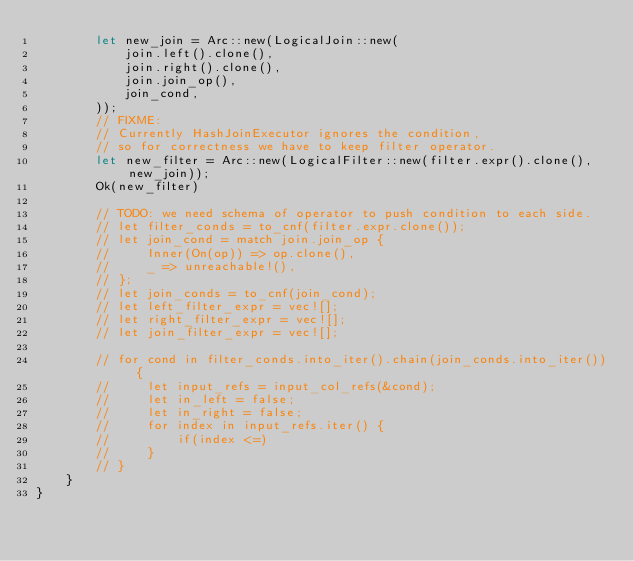<code> <loc_0><loc_0><loc_500><loc_500><_Rust_>        let new_join = Arc::new(LogicalJoin::new(
            join.left().clone(),
            join.right().clone(),
            join.join_op(),
            join_cond,
        ));
        // FIXME:
        // Currently HashJoinExecutor ignores the condition,
        // so for correctness we have to keep filter operator.
        let new_filter = Arc::new(LogicalFilter::new(filter.expr().clone(), new_join));
        Ok(new_filter)

        // TODO: we need schema of operator to push condition to each side.
        // let filter_conds = to_cnf(filter.expr.clone());
        // let join_cond = match join.join_op {
        //     Inner(On(op)) => op.clone(),
        //     _ => unreachable!(),
        // };
        // let join_conds = to_cnf(join_cond);
        // let left_filter_expr = vec![];
        // let right_filter_expr = vec![];
        // let join_filter_expr = vec![];

        // for cond in filter_conds.into_iter().chain(join_conds.into_iter()) {
        //     let input_refs = input_col_refs(&cond);
        //     let in_left = false;
        //     let in_right = false;
        //     for index in input_refs.iter() {
        //         if(index <=)
        //     }
        // }
    }
}
</code> 